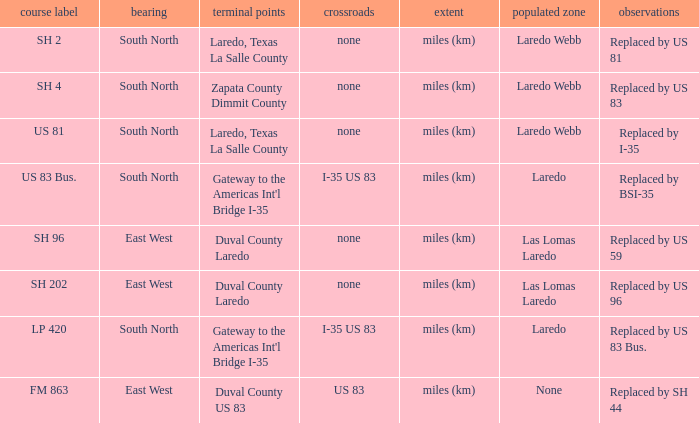Which population areas have "replaced by us 83" listed in their remarks section? Laredo Webb. 